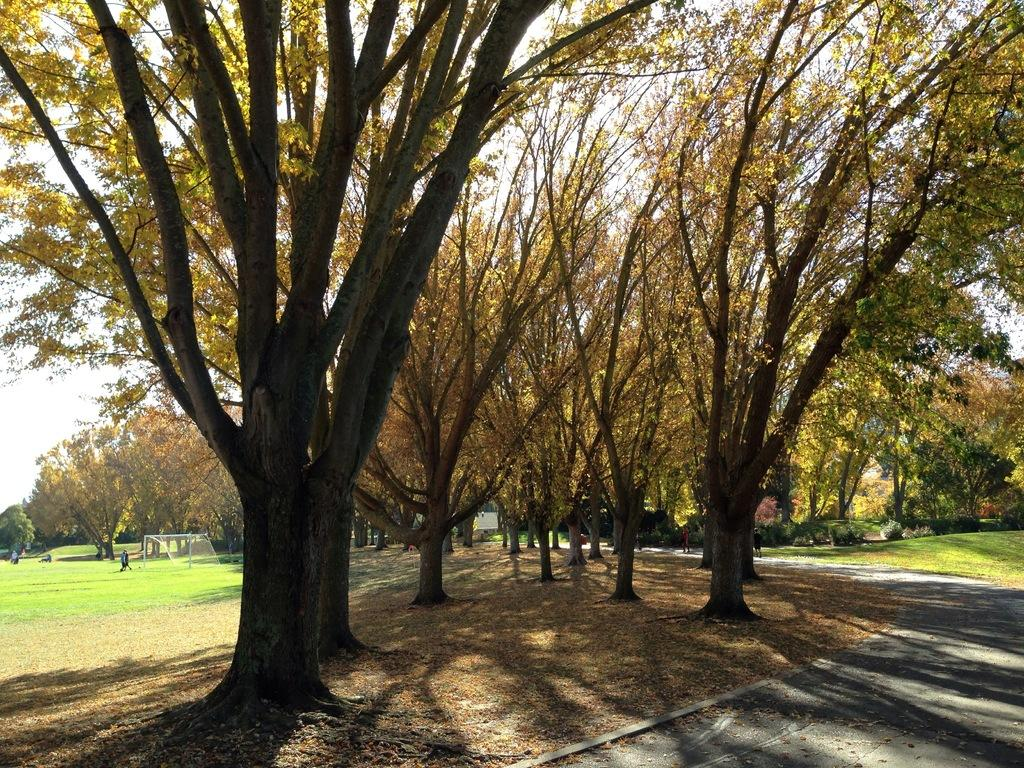What type of vegetation can be seen in the image? There are trees in the image. What else can be seen on the ground in the image? There is grass in the image. Are there any people present in the image? Yes, there are persons in the image. What type of pathway is visible in the image? There is a road in the image. What part of the natural environment is visible in the image? The sky is visible in the image. Where is the shelf located in the image? There is no shelf present in the image. What type of lunch is being served to the persons in the image? There is no lunch being served in the image; it only shows trees, grass, persons, a road, and the sky. 